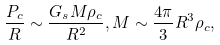Convert formula to latex. <formula><loc_0><loc_0><loc_500><loc_500>\frac { P _ { c } } { R } \sim \frac { G _ { s } M \rho _ { c } } { R ^ { 2 } } , M \sim \frac { 4 \pi } { 3 } R ^ { 3 } \rho _ { c } ,</formula> 